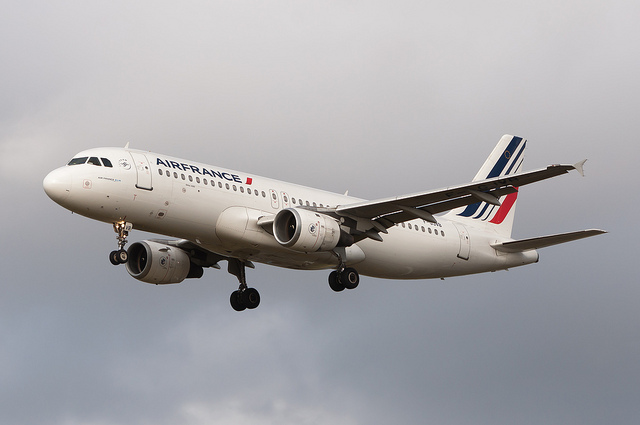Identify the text contained in this image. AIRFORCE 